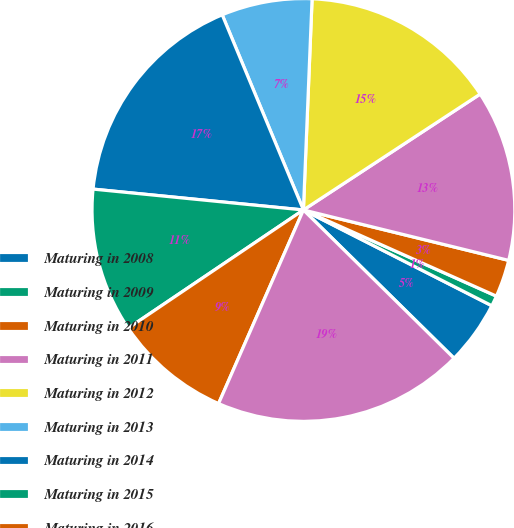<chart> <loc_0><loc_0><loc_500><loc_500><pie_chart><fcel>Maturing in 2008<fcel>Maturing in 2009<fcel>Maturing in 2010<fcel>Maturing in 2011<fcel>Maturing in 2012<fcel>Maturing in 2013<fcel>Maturing in 2014<fcel>Maturing in 2015<fcel>Maturing in 2016<fcel>Maturing in 2017 and beyond<nl><fcel>4.89%<fcel>0.8%<fcel>2.85%<fcel>13.07%<fcel>15.11%<fcel>6.93%<fcel>17.15%<fcel>11.02%<fcel>8.98%<fcel>19.2%<nl></chart> 